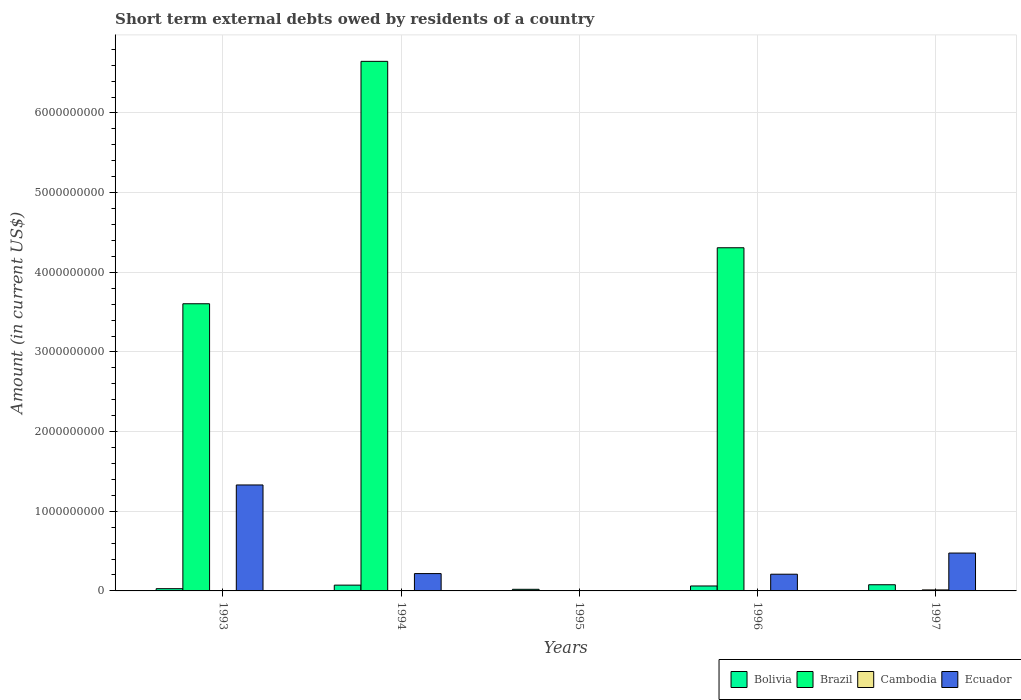Are the number of bars per tick equal to the number of legend labels?
Keep it short and to the point. No. Are the number of bars on each tick of the X-axis equal?
Your answer should be compact. No. How many bars are there on the 5th tick from the left?
Provide a short and direct response. 3. How many bars are there on the 5th tick from the right?
Offer a terse response. 3. What is the amount of short-term external debts owed by residents in Brazil in 1997?
Offer a very short reply. 0. Across all years, what is the maximum amount of short-term external debts owed by residents in Ecuador?
Provide a short and direct response. 1.33e+09. Across all years, what is the minimum amount of short-term external debts owed by residents in Bolivia?
Provide a succinct answer. 2.04e+07. What is the total amount of short-term external debts owed by residents in Ecuador in the graph?
Offer a terse response. 2.23e+09. What is the difference between the amount of short-term external debts owed by residents in Cambodia in 1996 and that in 1997?
Ensure brevity in your answer.  -1.13e+07. What is the difference between the amount of short-term external debts owed by residents in Brazil in 1997 and the amount of short-term external debts owed by residents in Cambodia in 1994?
Your answer should be compact. 0. What is the average amount of short-term external debts owed by residents in Brazil per year?
Provide a short and direct response. 2.91e+09. In the year 1996, what is the difference between the amount of short-term external debts owed by residents in Brazil and amount of short-term external debts owed by residents in Ecuador?
Your answer should be compact. 4.10e+09. What is the ratio of the amount of short-term external debts owed by residents in Ecuador in 1993 to that in 1994?
Provide a succinct answer. 6.11. Is the amount of short-term external debts owed by residents in Brazil in 1993 less than that in 1994?
Ensure brevity in your answer.  Yes. Is the difference between the amount of short-term external debts owed by residents in Brazil in 1993 and 1994 greater than the difference between the amount of short-term external debts owed by residents in Ecuador in 1993 and 1994?
Ensure brevity in your answer.  No. What is the difference between the highest and the second highest amount of short-term external debts owed by residents in Brazil?
Give a very brief answer. 2.34e+09. What is the difference between the highest and the lowest amount of short-term external debts owed by residents in Cambodia?
Your response must be concise. 1.26e+07. In how many years, is the amount of short-term external debts owed by residents in Cambodia greater than the average amount of short-term external debts owed by residents in Cambodia taken over all years?
Keep it short and to the point. 1. Is it the case that in every year, the sum of the amount of short-term external debts owed by residents in Ecuador and amount of short-term external debts owed by residents in Bolivia is greater than the sum of amount of short-term external debts owed by residents in Brazil and amount of short-term external debts owed by residents in Cambodia?
Offer a very short reply. No. Is it the case that in every year, the sum of the amount of short-term external debts owed by residents in Cambodia and amount of short-term external debts owed by residents in Bolivia is greater than the amount of short-term external debts owed by residents in Brazil?
Provide a succinct answer. No. How many years are there in the graph?
Make the answer very short. 5. How many legend labels are there?
Your answer should be very brief. 4. How are the legend labels stacked?
Your answer should be very brief. Horizontal. What is the title of the graph?
Your answer should be compact. Short term external debts owed by residents of a country. What is the label or title of the Y-axis?
Provide a succinct answer. Amount (in current US$). What is the Amount (in current US$) of Bolivia in 1993?
Your answer should be compact. 2.82e+07. What is the Amount (in current US$) of Brazil in 1993?
Provide a short and direct response. 3.60e+09. What is the Amount (in current US$) of Cambodia in 1993?
Your answer should be compact. 0. What is the Amount (in current US$) of Ecuador in 1993?
Offer a terse response. 1.33e+09. What is the Amount (in current US$) in Bolivia in 1994?
Give a very brief answer. 7.26e+07. What is the Amount (in current US$) of Brazil in 1994?
Keep it short and to the point. 6.65e+09. What is the Amount (in current US$) of Ecuador in 1994?
Provide a succinct answer. 2.18e+08. What is the Amount (in current US$) of Bolivia in 1995?
Give a very brief answer. 2.04e+07. What is the Amount (in current US$) of Brazil in 1995?
Your response must be concise. 0. What is the Amount (in current US$) in Cambodia in 1995?
Offer a terse response. 0. What is the Amount (in current US$) in Ecuador in 1995?
Your answer should be very brief. 0. What is the Amount (in current US$) of Bolivia in 1996?
Your response must be concise. 6.21e+07. What is the Amount (in current US$) in Brazil in 1996?
Provide a short and direct response. 4.31e+09. What is the Amount (in current US$) of Cambodia in 1996?
Your answer should be very brief. 1.34e+06. What is the Amount (in current US$) of Ecuador in 1996?
Provide a succinct answer. 2.10e+08. What is the Amount (in current US$) of Bolivia in 1997?
Make the answer very short. 7.76e+07. What is the Amount (in current US$) in Cambodia in 1997?
Offer a very short reply. 1.26e+07. What is the Amount (in current US$) in Ecuador in 1997?
Keep it short and to the point. 4.75e+08. Across all years, what is the maximum Amount (in current US$) of Bolivia?
Give a very brief answer. 7.76e+07. Across all years, what is the maximum Amount (in current US$) of Brazil?
Offer a terse response. 6.65e+09. Across all years, what is the maximum Amount (in current US$) in Cambodia?
Give a very brief answer. 1.26e+07. Across all years, what is the maximum Amount (in current US$) of Ecuador?
Your answer should be very brief. 1.33e+09. Across all years, what is the minimum Amount (in current US$) of Bolivia?
Your answer should be very brief. 2.04e+07. What is the total Amount (in current US$) in Bolivia in the graph?
Provide a succinct answer. 2.61e+08. What is the total Amount (in current US$) in Brazil in the graph?
Ensure brevity in your answer.  1.46e+1. What is the total Amount (in current US$) of Cambodia in the graph?
Ensure brevity in your answer.  1.40e+07. What is the total Amount (in current US$) in Ecuador in the graph?
Offer a very short reply. 2.23e+09. What is the difference between the Amount (in current US$) of Bolivia in 1993 and that in 1994?
Provide a short and direct response. -4.44e+07. What is the difference between the Amount (in current US$) of Brazil in 1993 and that in 1994?
Keep it short and to the point. -3.04e+09. What is the difference between the Amount (in current US$) of Ecuador in 1993 and that in 1994?
Make the answer very short. 1.11e+09. What is the difference between the Amount (in current US$) in Bolivia in 1993 and that in 1995?
Give a very brief answer. 7.83e+06. What is the difference between the Amount (in current US$) in Bolivia in 1993 and that in 1996?
Make the answer very short. -3.38e+07. What is the difference between the Amount (in current US$) of Brazil in 1993 and that in 1996?
Make the answer very short. -7.03e+08. What is the difference between the Amount (in current US$) in Ecuador in 1993 and that in 1996?
Your answer should be very brief. 1.12e+09. What is the difference between the Amount (in current US$) in Bolivia in 1993 and that in 1997?
Offer a terse response. -4.94e+07. What is the difference between the Amount (in current US$) in Ecuador in 1993 and that in 1997?
Offer a terse response. 8.55e+08. What is the difference between the Amount (in current US$) of Bolivia in 1994 and that in 1995?
Make the answer very short. 5.22e+07. What is the difference between the Amount (in current US$) in Bolivia in 1994 and that in 1996?
Give a very brief answer. 1.05e+07. What is the difference between the Amount (in current US$) in Brazil in 1994 and that in 1996?
Your answer should be very brief. 2.34e+09. What is the difference between the Amount (in current US$) in Ecuador in 1994 and that in 1996?
Provide a succinct answer. 7.82e+06. What is the difference between the Amount (in current US$) in Bolivia in 1994 and that in 1997?
Give a very brief answer. -4.97e+06. What is the difference between the Amount (in current US$) in Ecuador in 1994 and that in 1997?
Offer a terse response. -2.58e+08. What is the difference between the Amount (in current US$) of Bolivia in 1995 and that in 1996?
Your answer should be compact. -4.17e+07. What is the difference between the Amount (in current US$) in Bolivia in 1995 and that in 1997?
Provide a short and direct response. -5.72e+07. What is the difference between the Amount (in current US$) of Bolivia in 1996 and that in 1997?
Your answer should be very brief. -1.55e+07. What is the difference between the Amount (in current US$) in Cambodia in 1996 and that in 1997?
Keep it short and to the point. -1.13e+07. What is the difference between the Amount (in current US$) in Ecuador in 1996 and that in 1997?
Offer a very short reply. -2.66e+08. What is the difference between the Amount (in current US$) of Bolivia in 1993 and the Amount (in current US$) of Brazil in 1994?
Make the answer very short. -6.62e+09. What is the difference between the Amount (in current US$) in Bolivia in 1993 and the Amount (in current US$) in Ecuador in 1994?
Provide a short and direct response. -1.89e+08. What is the difference between the Amount (in current US$) of Brazil in 1993 and the Amount (in current US$) of Ecuador in 1994?
Provide a succinct answer. 3.39e+09. What is the difference between the Amount (in current US$) of Bolivia in 1993 and the Amount (in current US$) of Brazil in 1996?
Provide a short and direct response. -4.28e+09. What is the difference between the Amount (in current US$) in Bolivia in 1993 and the Amount (in current US$) in Cambodia in 1996?
Ensure brevity in your answer.  2.69e+07. What is the difference between the Amount (in current US$) in Bolivia in 1993 and the Amount (in current US$) in Ecuador in 1996?
Offer a terse response. -1.82e+08. What is the difference between the Amount (in current US$) of Brazil in 1993 and the Amount (in current US$) of Cambodia in 1996?
Offer a very short reply. 3.60e+09. What is the difference between the Amount (in current US$) in Brazil in 1993 and the Amount (in current US$) in Ecuador in 1996?
Make the answer very short. 3.40e+09. What is the difference between the Amount (in current US$) in Bolivia in 1993 and the Amount (in current US$) in Cambodia in 1997?
Provide a short and direct response. 1.56e+07. What is the difference between the Amount (in current US$) of Bolivia in 1993 and the Amount (in current US$) of Ecuador in 1997?
Offer a very short reply. -4.47e+08. What is the difference between the Amount (in current US$) of Brazil in 1993 and the Amount (in current US$) of Cambodia in 1997?
Offer a terse response. 3.59e+09. What is the difference between the Amount (in current US$) of Brazil in 1993 and the Amount (in current US$) of Ecuador in 1997?
Ensure brevity in your answer.  3.13e+09. What is the difference between the Amount (in current US$) of Bolivia in 1994 and the Amount (in current US$) of Brazil in 1996?
Ensure brevity in your answer.  -4.24e+09. What is the difference between the Amount (in current US$) in Bolivia in 1994 and the Amount (in current US$) in Cambodia in 1996?
Offer a terse response. 7.12e+07. What is the difference between the Amount (in current US$) of Bolivia in 1994 and the Amount (in current US$) of Ecuador in 1996?
Ensure brevity in your answer.  -1.37e+08. What is the difference between the Amount (in current US$) in Brazil in 1994 and the Amount (in current US$) in Cambodia in 1996?
Ensure brevity in your answer.  6.65e+09. What is the difference between the Amount (in current US$) in Brazil in 1994 and the Amount (in current US$) in Ecuador in 1996?
Ensure brevity in your answer.  6.44e+09. What is the difference between the Amount (in current US$) in Bolivia in 1994 and the Amount (in current US$) in Cambodia in 1997?
Keep it short and to the point. 6.00e+07. What is the difference between the Amount (in current US$) in Bolivia in 1994 and the Amount (in current US$) in Ecuador in 1997?
Keep it short and to the point. -4.03e+08. What is the difference between the Amount (in current US$) of Brazil in 1994 and the Amount (in current US$) of Cambodia in 1997?
Make the answer very short. 6.64e+09. What is the difference between the Amount (in current US$) in Brazil in 1994 and the Amount (in current US$) in Ecuador in 1997?
Your response must be concise. 6.17e+09. What is the difference between the Amount (in current US$) in Bolivia in 1995 and the Amount (in current US$) in Brazil in 1996?
Make the answer very short. -4.29e+09. What is the difference between the Amount (in current US$) of Bolivia in 1995 and the Amount (in current US$) of Cambodia in 1996?
Provide a succinct answer. 1.90e+07. What is the difference between the Amount (in current US$) of Bolivia in 1995 and the Amount (in current US$) of Ecuador in 1996?
Provide a succinct answer. -1.89e+08. What is the difference between the Amount (in current US$) in Bolivia in 1995 and the Amount (in current US$) in Cambodia in 1997?
Offer a terse response. 7.76e+06. What is the difference between the Amount (in current US$) of Bolivia in 1995 and the Amount (in current US$) of Ecuador in 1997?
Offer a very short reply. -4.55e+08. What is the difference between the Amount (in current US$) in Bolivia in 1996 and the Amount (in current US$) in Cambodia in 1997?
Provide a succinct answer. 4.94e+07. What is the difference between the Amount (in current US$) of Bolivia in 1996 and the Amount (in current US$) of Ecuador in 1997?
Your answer should be compact. -4.13e+08. What is the difference between the Amount (in current US$) in Brazil in 1996 and the Amount (in current US$) in Cambodia in 1997?
Provide a succinct answer. 4.30e+09. What is the difference between the Amount (in current US$) of Brazil in 1996 and the Amount (in current US$) of Ecuador in 1997?
Ensure brevity in your answer.  3.83e+09. What is the difference between the Amount (in current US$) of Cambodia in 1996 and the Amount (in current US$) of Ecuador in 1997?
Offer a very short reply. -4.74e+08. What is the average Amount (in current US$) of Bolivia per year?
Make the answer very short. 5.22e+07. What is the average Amount (in current US$) in Brazil per year?
Ensure brevity in your answer.  2.91e+09. What is the average Amount (in current US$) in Cambodia per year?
Your response must be concise. 2.79e+06. What is the average Amount (in current US$) of Ecuador per year?
Your response must be concise. 4.47e+08. In the year 1993, what is the difference between the Amount (in current US$) in Bolivia and Amount (in current US$) in Brazil?
Provide a short and direct response. -3.58e+09. In the year 1993, what is the difference between the Amount (in current US$) of Bolivia and Amount (in current US$) of Ecuador?
Your answer should be very brief. -1.30e+09. In the year 1993, what is the difference between the Amount (in current US$) of Brazil and Amount (in current US$) of Ecuador?
Your answer should be compact. 2.27e+09. In the year 1994, what is the difference between the Amount (in current US$) in Bolivia and Amount (in current US$) in Brazil?
Ensure brevity in your answer.  -6.58e+09. In the year 1994, what is the difference between the Amount (in current US$) of Bolivia and Amount (in current US$) of Ecuador?
Provide a short and direct response. -1.45e+08. In the year 1994, what is the difference between the Amount (in current US$) of Brazil and Amount (in current US$) of Ecuador?
Make the answer very short. 6.43e+09. In the year 1996, what is the difference between the Amount (in current US$) of Bolivia and Amount (in current US$) of Brazil?
Provide a succinct answer. -4.25e+09. In the year 1996, what is the difference between the Amount (in current US$) in Bolivia and Amount (in current US$) in Cambodia?
Offer a very short reply. 6.07e+07. In the year 1996, what is the difference between the Amount (in current US$) of Bolivia and Amount (in current US$) of Ecuador?
Ensure brevity in your answer.  -1.48e+08. In the year 1996, what is the difference between the Amount (in current US$) of Brazil and Amount (in current US$) of Cambodia?
Offer a terse response. 4.31e+09. In the year 1996, what is the difference between the Amount (in current US$) in Brazil and Amount (in current US$) in Ecuador?
Give a very brief answer. 4.10e+09. In the year 1996, what is the difference between the Amount (in current US$) of Cambodia and Amount (in current US$) of Ecuador?
Offer a very short reply. -2.08e+08. In the year 1997, what is the difference between the Amount (in current US$) of Bolivia and Amount (in current US$) of Cambodia?
Offer a very short reply. 6.49e+07. In the year 1997, what is the difference between the Amount (in current US$) of Bolivia and Amount (in current US$) of Ecuador?
Offer a terse response. -3.98e+08. In the year 1997, what is the difference between the Amount (in current US$) in Cambodia and Amount (in current US$) in Ecuador?
Make the answer very short. -4.63e+08. What is the ratio of the Amount (in current US$) in Bolivia in 1993 to that in 1994?
Ensure brevity in your answer.  0.39. What is the ratio of the Amount (in current US$) in Brazil in 1993 to that in 1994?
Your answer should be compact. 0.54. What is the ratio of the Amount (in current US$) in Ecuador in 1993 to that in 1994?
Ensure brevity in your answer.  6.11. What is the ratio of the Amount (in current US$) in Bolivia in 1993 to that in 1995?
Make the answer very short. 1.38. What is the ratio of the Amount (in current US$) of Bolivia in 1993 to that in 1996?
Keep it short and to the point. 0.45. What is the ratio of the Amount (in current US$) in Brazil in 1993 to that in 1996?
Keep it short and to the point. 0.84. What is the ratio of the Amount (in current US$) in Ecuador in 1993 to that in 1996?
Keep it short and to the point. 6.34. What is the ratio of the Amount (in current US$) of Bolivia in 1993 to that in 1997?
Make the answer very short. 0.36. What is the ratio of the Amount (in current US$) in Ecuador in 1993 to that in 1997?
Make the answer very short. 2.8. What is the ratio of the Amount (in current US$) of Bolivia in 1994 to that in 1995?
Offer a very short reply. 3.56. What is the ratio of the Amount (in current US$) of Bolivia in 1994 to that in 1996?
Offer a very short reply. 1.17. What is the ratio of the Amount (in current US$) of Brazil in 1994 to that in 1996?
Offer a terse response. 1.54. What is the ratio of the Amount (in current US$) of Ecuador in 1994 to that in 1996?
Provide a short and direct response. 1.04. What is the ratio of the Amount (in current US$) of Bolivia in 1994 to that in 1997?
Your response must be concise. 0.94. What is the ratio of the Amount (in current US$) of Ecuador in 1994 to that in 1997?
Provide a short and direct response. 0.46. What is the ratio of the Amount (in current US$) in Bolivia in 1995 to that in 1996?
Give a very brief answer. 0.33. What is the ratio of the Amount (in current US$) of Bolivia in 1995 to that in 1997?
Your answer should be compact. 0.26. What is the ratio of the Amount (in current US$) of Bolivia in 1996 to that in 1997?
Provide a short and direct response. 0.8. What is the ratio of the Amount (in current US$) in Cambodia in 1996 to that in 1997?
Offer a very short reply. 0.11. What is the ratio of the Amount (in current US$) in Ecuador in 1996 to that in 1997?
Provide a short and direct response. 0.44. What is the difference between the highest and the second highest Amount (in current US$) in Bolivia?
Provide a short and direct response. 4.97e+06. What is the difference between the highest and the second highest Amount (in current US$) in Brazil?
Keep it short and to the point. 2.34e+09. What is the difference between the highest and the second highest Amount (in current US$) of Ecuador?
Offer a very short reply. 8.55e+08. What is the difference between the highest and the lowest Amount (in current US$) in Bolivia?
Offer a very short reply. 5.72e+07. What is the difference between the highest and the lowest Amount (in current US$) in Brazil?
Your response must be concise. 6.65e+09. What is the difference between the highest and the lowest Amount (in current US$) in Cambodia?
Make the answer very short. 1.26e+07. What is the difference between the highest and the lowest Amount (in current US$) in Ecuador?
Give a very brief answer. 1.33e+09. 